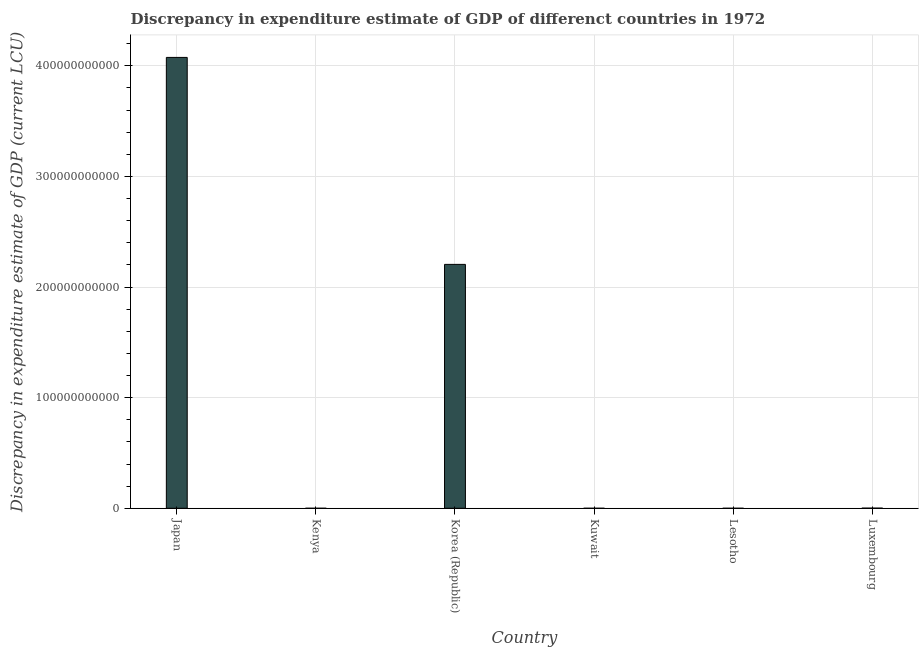Does the graph contain any zero values?
Your answer should be very brief. No. Does the graph contain grids?
Ensure brevity in your answer.  Yes. What is the title of the graph?
Your answer should be very brief. Discrepancy in expenditure estimate of GDP of differenct countries in 1972. What is the label or title of the Y-axis?
Provide a short and direct response. Discrepancy in expenditure estimate of GDP (current LCU). What is the discrepancy in expenditure estimate of gdp in Luxembourg?
Give a very brief answer. 1.18e+08. Across all countries, what is the maximum discrepancy in expenditure estimate of gdp?
Offer a very short reply. 4.08e+11. Across all countries, what is the minimum discrepancy in expenditure estimate of gdp?
Ensure brevity in your answer.  7e-9. In which country was the discrepancy in expenditure estimate of gdp maximum?
Your answer should be compact. Japan. In which country was the discrepancy in expenditure estimate of gdp minimum?
Your response must be concise. Lesotho. What is the sum of the discrepancy in expenditure estimate of gdp?
Your response must be concise. 6.28e+11. What is the difference between the discrepancy in expenditure estimate of gdp in Japan and Kenya?
Keep it short and to the point. 4.08e+11. What is the average discrepancy in expenditure estimate of gdp per country?
Offer a very short reply. 1.05e+11. What is the median discrepancy in expenditure estimate of gdp?
Give a very brief answer. 6.03e+07. In how many countries, is the discrepancy in expenditure estimate of gdp greater than 240000000000 LCU?
Provide a short and direct response. 1. What is the ratio of the discrepancy in expenditure estimate of gdp in Japan to that in Kuwait?
Give a very brief answer. 4.52904225e+18. Is the discrepancy in expenditure estimate of gdp in Kuwait less than that in Lesotho?
Make the answer very short. No. What is the difference between the highest and the second highest discrepancy in expenditure estimate of gdp?
Keep it short and to the point. 1.87e+11. Is the sum of the discrepancy in expenditure estimate of gdp in Kuwait and Lesotho greater than the maximum discrepancy in expenditure estimate of gdp across all countries?
Your response must be concise. No. What is the difference between the highest and the lowest discrepancy in expenditure estimate of gdp?
Your response must be concise. 4.08e+11. What is the difference between two consecutive major ticks on the Y-axis?
Offer a terse response. 1.00e+11. What is the Discrepancy in expenditure estimate of GDP (current LCU) of Japan?
Offer a terse response. 4.08e+11. What is the Discrepancy in expenditure estimate of GDP (current LCU) in Kenya?
Make the answer very short. 2.80e+06. What is the Discrepancy in expenditure estimate of GDP (current LCU) in Korea (Republic)?
Ensure brevity in your answer.  2.20e+11. What is the Discrepancy in expenditure estimate of GDP (current LCU) in Kuwait?
Offer a terse response. 9e-8. What is the Discrepancy in expenditure estimate of GDP (current LCU) of Lesotho?
Keep it short and to the point. 7e-9. What is the Discrepancy in expenditure estimate of GDP (current LCU) in Luxembourg?
Give a very brief answer. 1.18e+08. What is the difference between the Discrepancy in expenditure estimate of GDP (current LCU) in Japan and Kenya?
Give a very brief answer. 4.08e+11. What is the difference between the Discrepancy in expenditure estimate of GDP (current LCU) in Japan and Korea (Republic)?
Your response must be concise. 1.87e+11. What is the difference between the Discrepancy in expenditure estimate of GDP (current LCU) in Japan and Kuwait?
Provide a succinct answer. 4.08e+11. What is the difference between the Discrepancy in expenditure estimate of GDP (current LCU) in Japan and Lesotho?
Your response must be concise. 4.08e+11. What is the difference between the Discrepancy in expenditure estimate of GDP (current LCU) in Japan and Luxembourg?
Ensure brevity in your answer.  4.07e+11. What is the difference between the Discrepancy in expenditure estimate of GDP (current LCU) in Kenya and Korea (Republic)?
Make the answer very short. -2.20e+11. What is the difference between the Discrepancy in expenditure estimate of GDP (current LCU) in Kenya and Kuwait?
Make the answer very short. 2.80e+06. What is the difference between the Discrepancy in expenditure estimate of GDP (current LCU) in Kenya and Lesotho?
Make the answer very short. 2.80e+06. What is the difference between the Discrepancy in expenditure estimate of GDP (current LCU) in Kenya and Luxembourg?
Your answer should be compact. -1.15e+08. What is the difference between the Discrepancy in expenditure estimate of GDP (current LCU) in Korea (Republic) and Kuwait?
Make the answer very short. 2.20e+11. What is the difference between the Discrepancy in expenditure estimate of GDP (current LCU) in Korea (Republic) and Lesotho?
Your response must be concise. 2.20e+11. What is the difference between the Discrepancy in expenditure estimate of GDP (current LCU) in Korea (Republic) and Luxembourg?
Provide a short and direct response. 2.20e+11. What is the difference between the Discrepancy in expenditure estimate of GDP (current LCU) in Kuwait and Luxembourg?
Provide a succinct answer. -1.18e+08. What is the difference between the Discrepancy in expenditure estimate of GDP (current LCU) in Lesotho and Luxembourg?
Offer a terse response. -1.18e+08. What is the ratio of the Discrepancy in expenditure estimate of GDP (current LCU) in Japan to that in Kenya?
Your answer should be compact. 1.46e+05. What is the ratio of the Discrepancy in expenditure estimate of GDP (current LCU) in Japan to that in Korea (Republic)?
Provide a short and direct response. 1.85. What is the ratio of the Discrepancy in expenditure estimate of GDP (current LCU) in Japan to that in Kuwait?
Provide a succinct answer. 4.52904225e+18. What is the ratio of the Discrepancy in expenditure estimate of GDP (current LCU) in Japan to that in Lesotho?
Ensure brevity in your answer.  5.823054321428572e+19. What is the ratio of the Discrepancy in expenditure estimate of GDP (current LCU) in Japan to that in Luxembourg?
Ensure brevity in your answer.  3461.77. What is the ratio of the Discrepancy in expenditure estimate of GDP (current LCU) in Kenya to that in Korea (Republic)?
Your answer should be compact. 0. What is the ratio of the Discrepancy in expenditure estimate of GDP (current LCU) in Kenya to that in Kuwait?
Your response must be concise. 3.11e+13. What is the ratio of the Discrepancy in expenditure estimate of GDP (current LCU) in Kenya to that in Lesotho?
Make the answer very short. 4.00e+14. What is the ratio of the Discrepancy in expenditure estimate of GDP (current LCU) in Kenya to that in Luxembourg?
Offer a very short reply. 0.02. What is the ratio of the Discrepancy in expenditure estimate of GDP (current LCU) in Korea (Republic) to that in Kuwait?
Provide a short and direct response. 2.45e+18. What is the ratio of the Discrepancy in expenditure estimate of GDP (current LCU) in Korea (Republic) to that in Lesotho?
Ensure brevity in your answer.  3.15e+19. What is the ratio of the Discrepancy in expenditure estimate of GDP (current LCU) in Korea (Republic) to that in Luxembourg?
Provide a succinct answer. 1872.66. What is the ratio of the Discrepancy in expenditure estimate of GDP (current LCU) in Kuwait to that in Lesotho?
Your answer should be compact. 12.86. What is the ratio of the Discrepancy in expenditure estimate of GDP (current LCU) in Kuwait to that in Luxembourg?
Offer a very short reply. 0. 